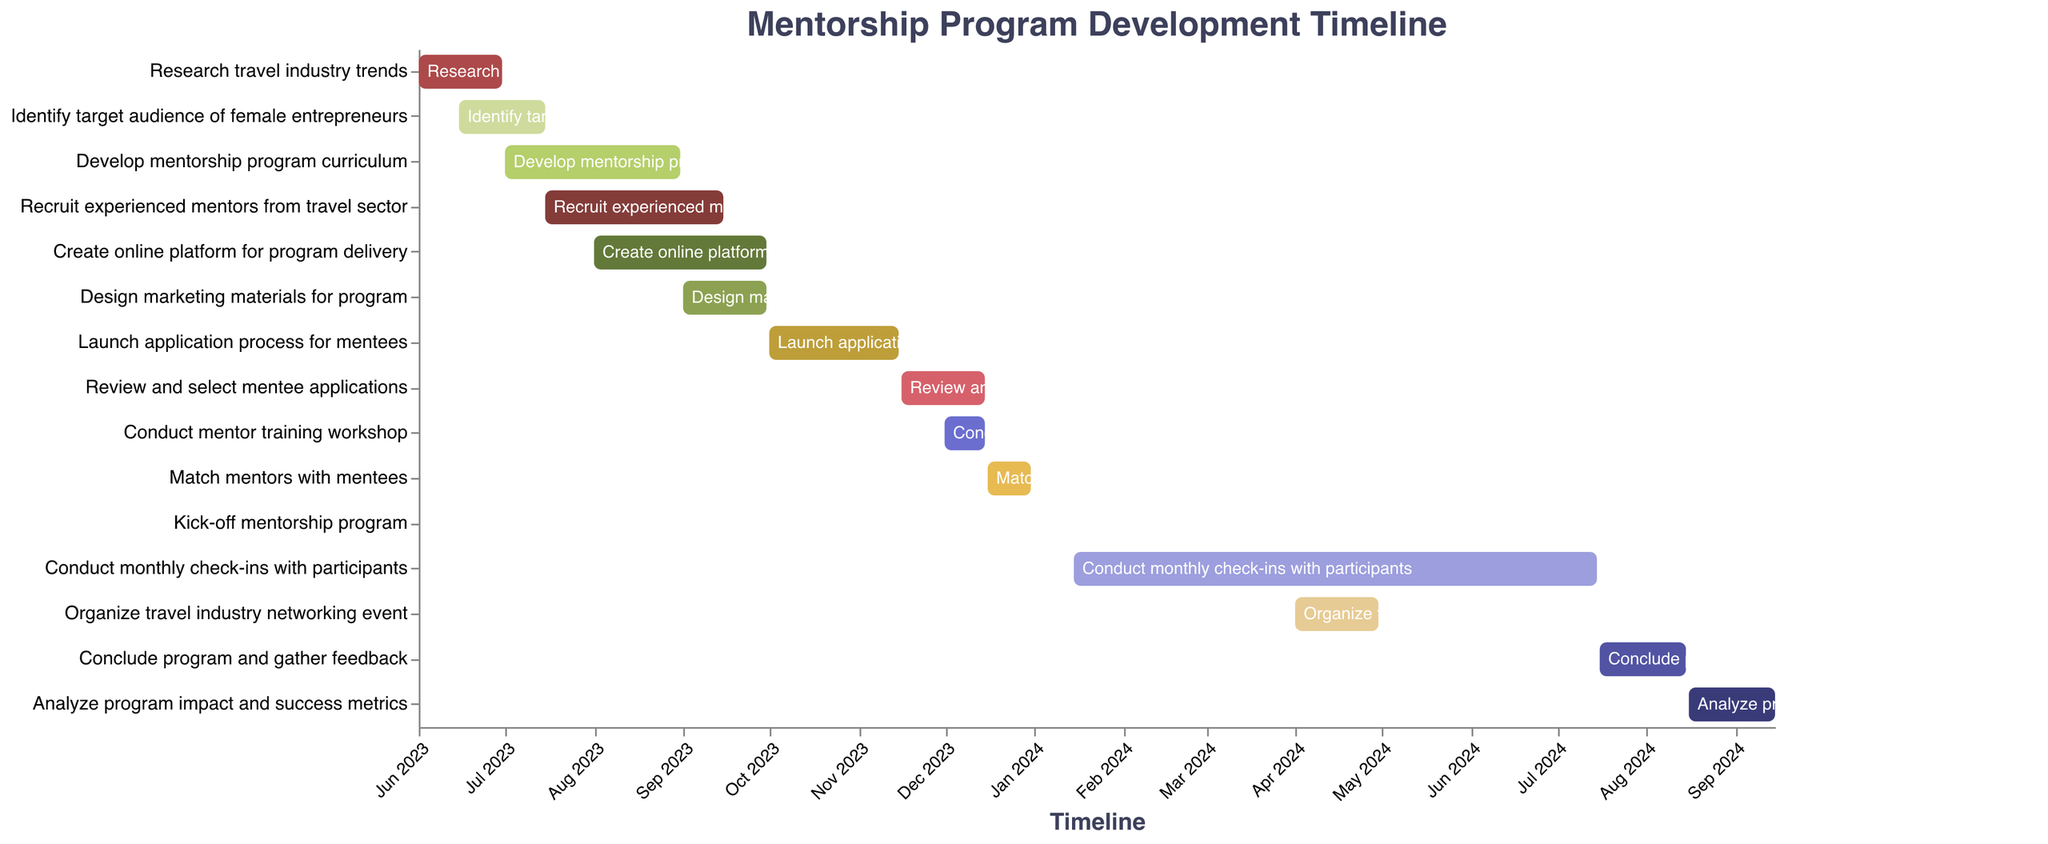What's the title of the figure? The title of the figure is displayed at the top and reads "Mentorship Program Development Timeline".
Answer: Mentorship Program Development Timeline How many tasks are listed in the Gantt Chart? Each task corresponds to a bar in the chart, and there are 15 bars representing different tasks.
Answer: 15 When does the "Research travel industry trends" task start and end? The "Research travel industry trends" task starts on June 1, 2023, and ends on June 30, 2023, as indicated by the horizontal bar for this task.
Answer: June 1, 2023 to June 30, 2023 Which task has the same start and end date? This can be found by looking for a task where the start and end dates are the same. The "Kick-off mentorship program" task has both its start and end dates on January 15, 2024.
Answer: Kick-off mentorship program Which task takes the longest to complete? To find the longest task, measure the duration from start to end dates for each. "Conduct monthly check-ins with participants" spans from January 15, 2024, to July 15, 2024, taking 6 months, which is the longest duration.
Answer: Conduct monthly check-ins with participants Which tasks overlap with the "Develop mentorship program curriculum" task? By comparing the start and end dates of "Develop mentorship program curriculum" (July 1, 2023, to August 31, 2023) with other tasks, the overlapping tasks are "Identify target audience of female entrepreneurs", "Recruit experienced mentors from travel sector", and "Create online platform for program delivery".
Answer: Identify target audience of female entrepreneurs, Recruit experienced mentors from travel sector, Create online platform for program delivery What is the gap between the end date of "Match mentors with mentees" and the start date of "Conduct monthly check-ins with participants"? The "Match mentors with mentees" task ends on December 31, 2023, and "Conduct monthly check-ins with participants" starts on January 15, 2024. The gap between these dates is 15 days.
Answer: 15 days How many tasks are scheduled to be completed by the end of 2023? Tasks completed by the end of 2023 end within December 31, 2023. This includes all tasks from “Research travel industry trends” to “Match mentors with mentees”, totaling 10 tasks.
Answer: 10 By which month of 2024 is the travel industry networking event scheduled? The travel industry networking event is scheduled from April 1, 2024, to April 30, 2024, as indicated by the corresponding task bar.
Answer: April 2024 When does the "Analyze program impact and success metrics" task begin and end? The "Analyze program impact and success metrics" task starts on August 16, 2024, and ends on September 15, 2024, as indicated by the dates for the task.
Answer: August 16, 2024 to September 15, 2024 